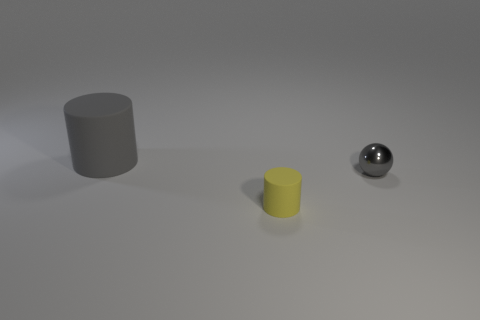What could be the possible materials of the objects based on their appearance in the image? Based on the visual characteristics, the gray cylinder and the yellow cylinder have a matte finish, which suggests they could be made from a material like painted wood or matte-finished plastic. The shiny gray ball, on the other hand, reflects light and has a mirror-like surface, indicating it could be made of polished metal or chrome. 